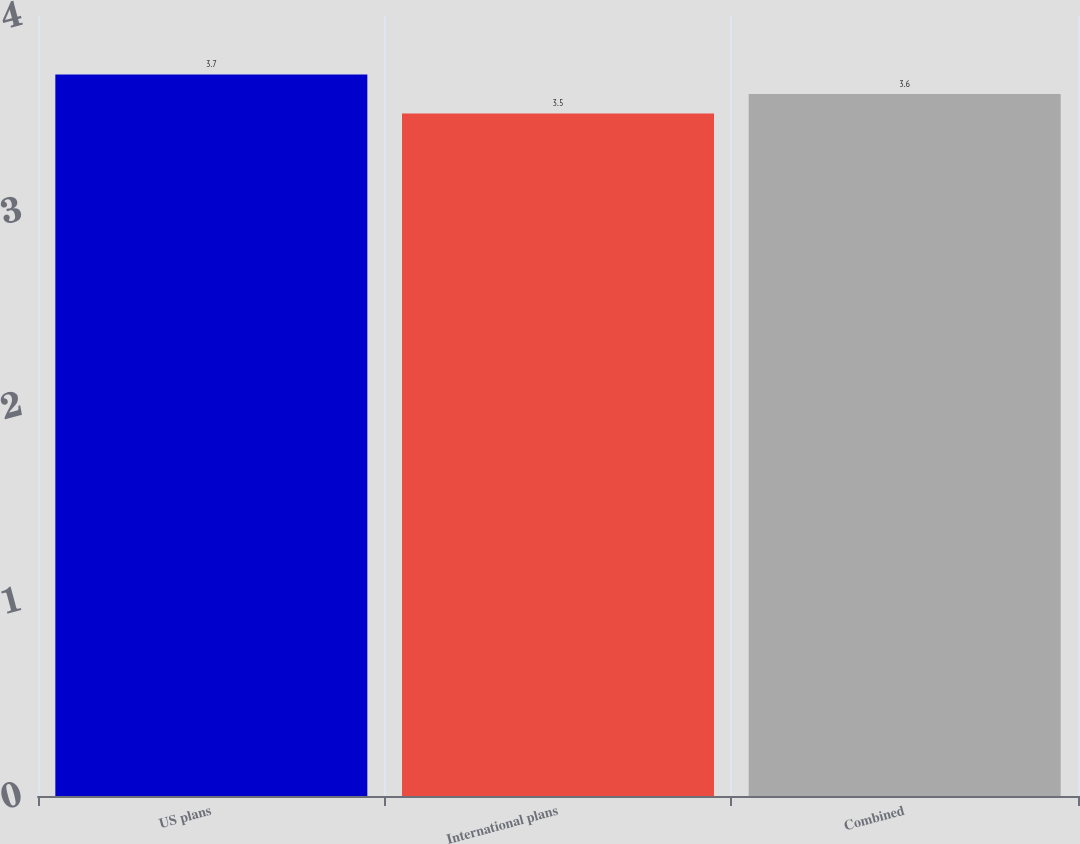Convert chart to OTSL. <chart><loc_0><loc_0><loc_500><loc_500><bar_chart><fcel>US plans<fcel>International plans<fcel>Combined<nl><fcel>3.7<fcel>3.5<fcel>3.6<nl></chart> 